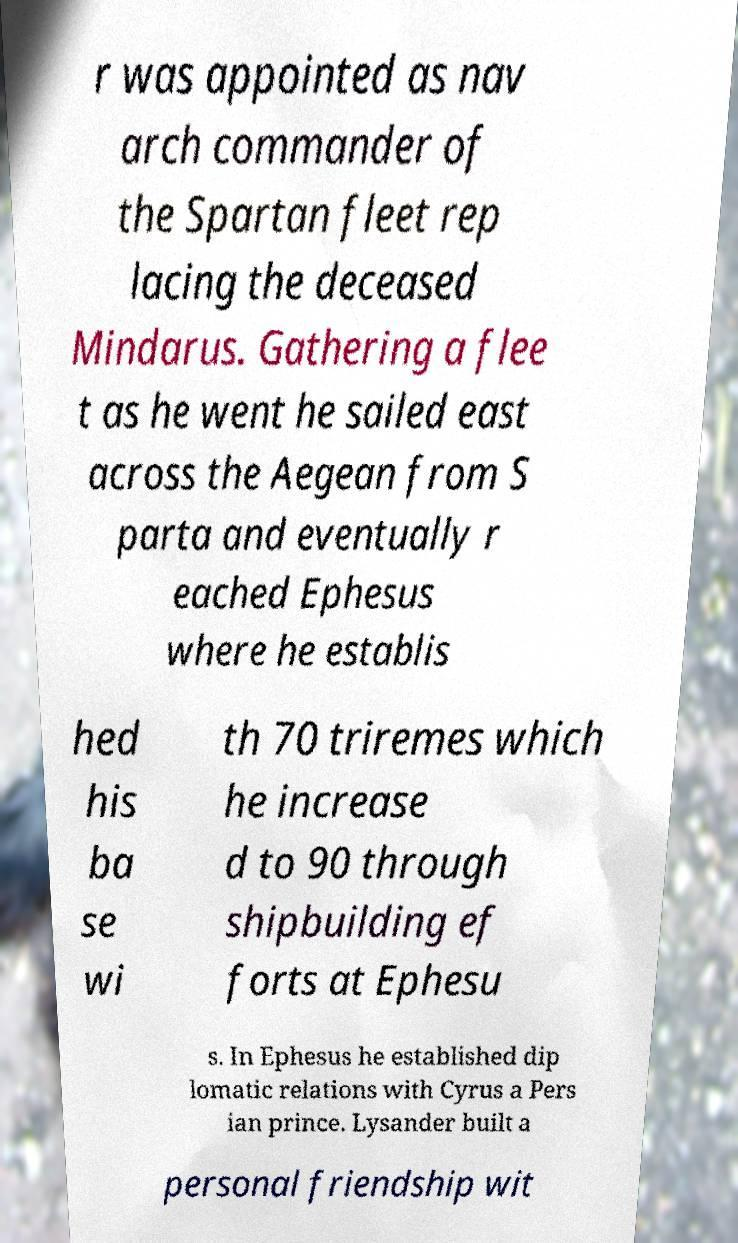Can you read and provide the text displayed in the image?This photo seems to have some interesting text. Can you extract and type it out for me? r was appointed as nav arch commander of the Spartan fleet rep lacing the deceased Mindarus. Gathering a flee t as he went he sailed east across the Aegean from S parta and eventually r eached Ephesus where he establis hed his ba se wi th 70 triremes which he increase d to 90 through shipbuilding ef forts at Ephesu s. In Ephesus he established dip lomatic relations with Cyrus a Pers ian prince. Lysander built a personal friendship wit 